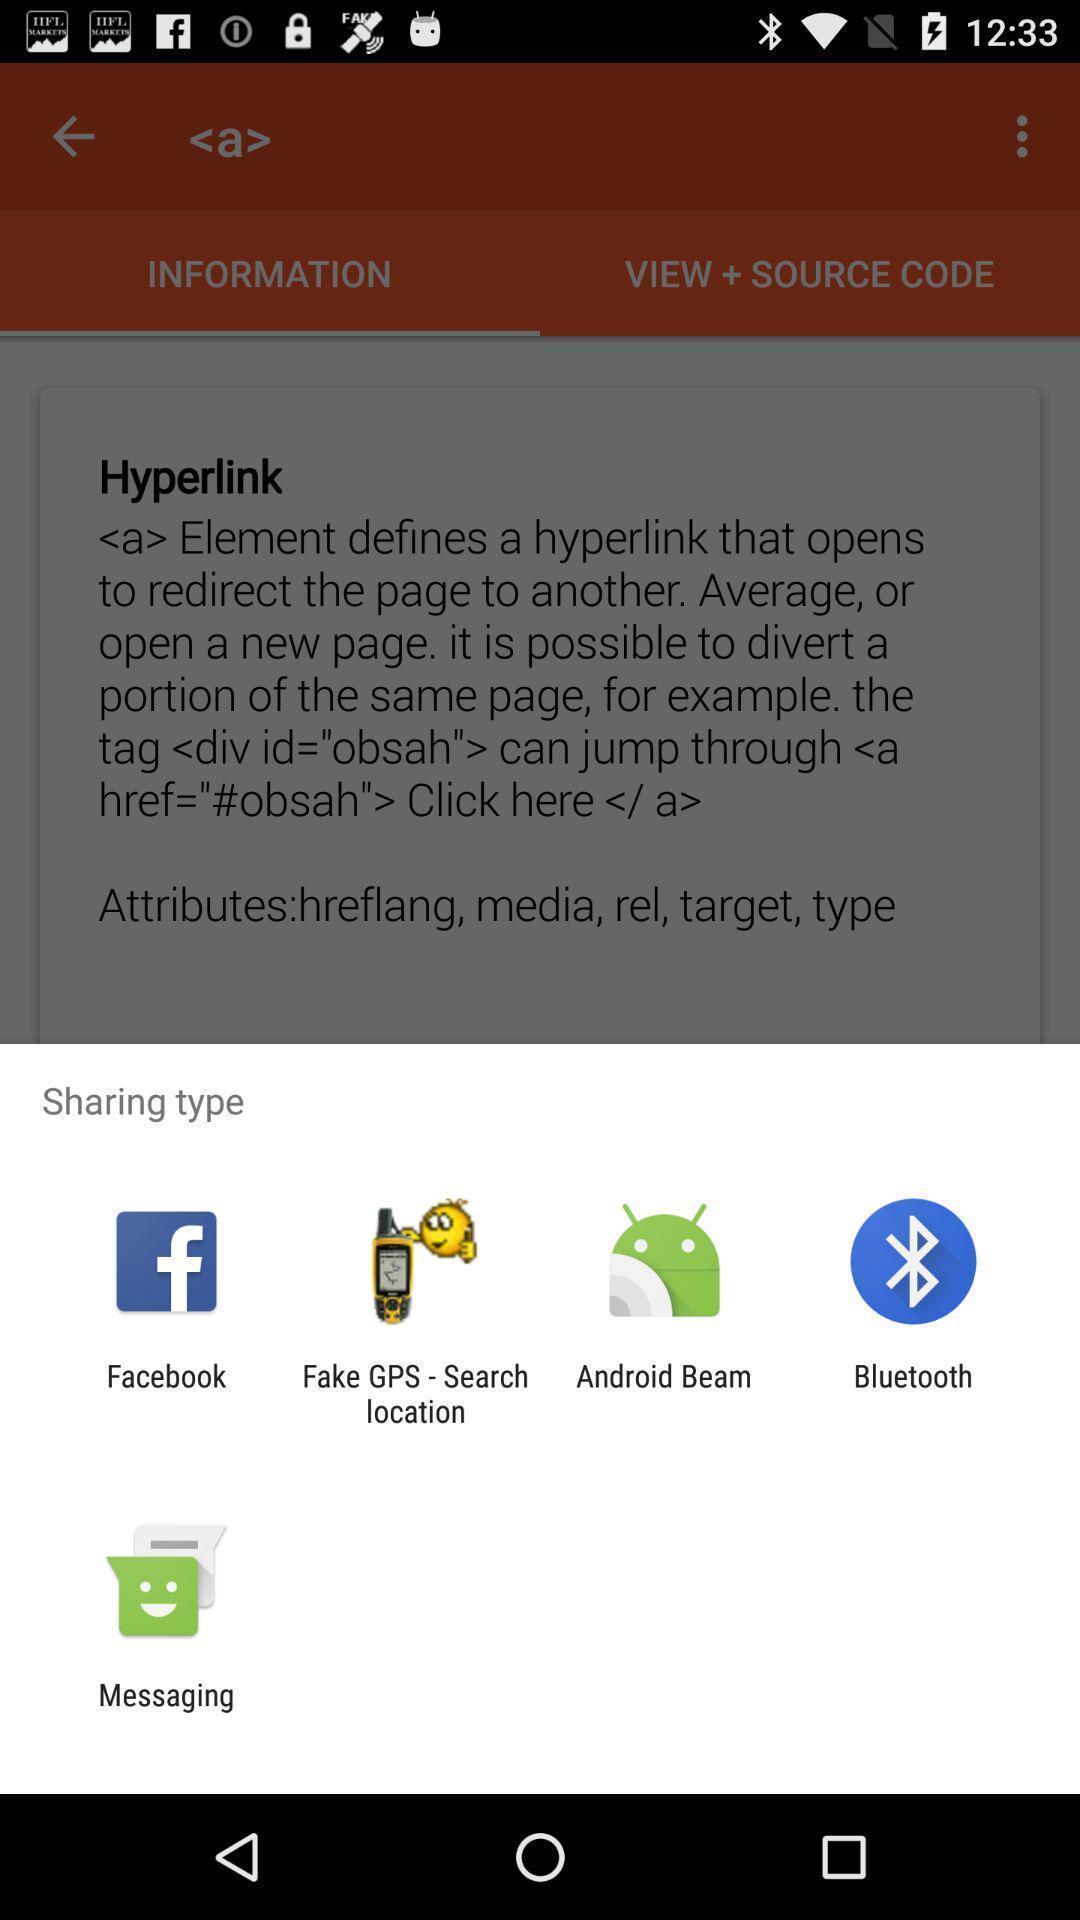Describe the visual elements of this screenshot. Push up message with sharing options. 